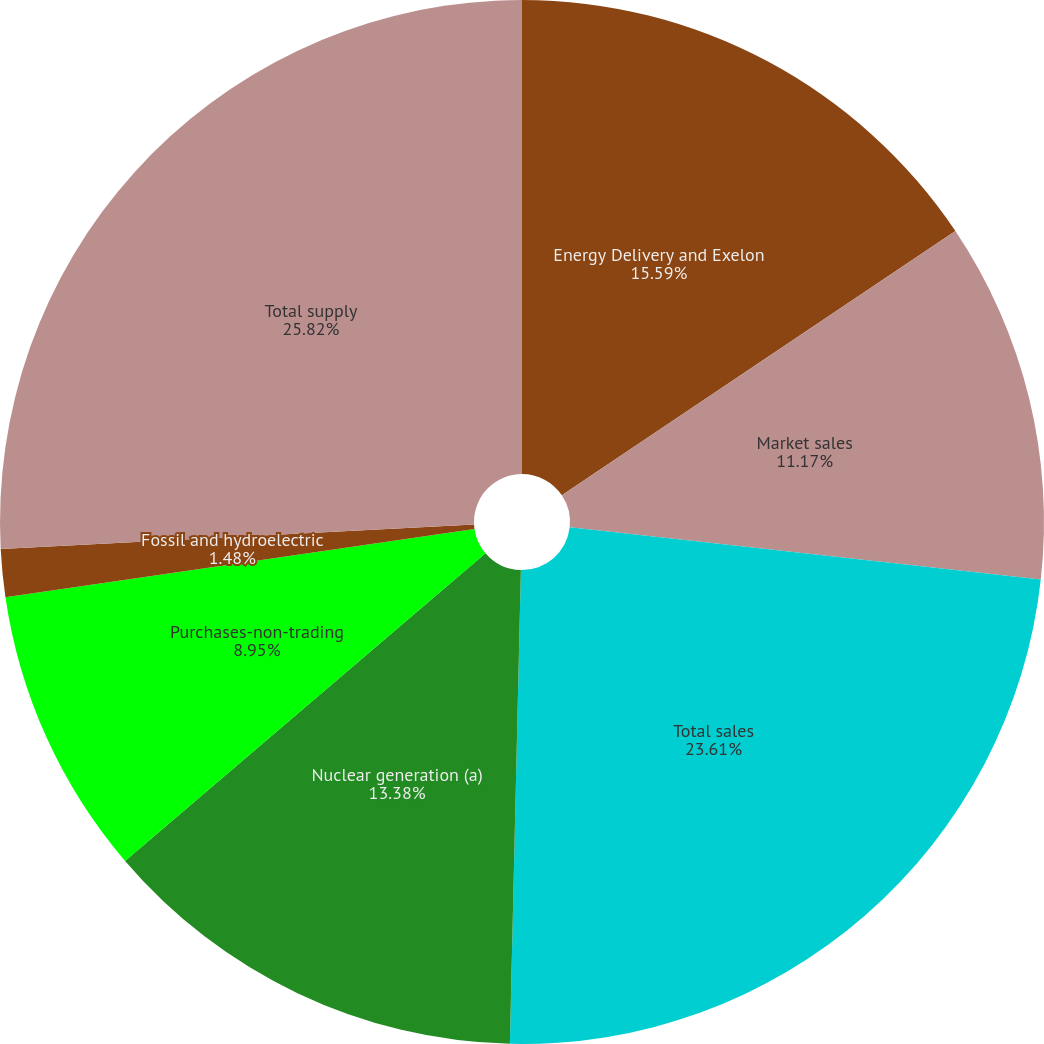<chart> <loc_0><loc_0><loc_500><loc_500><pie_chart><fcel>Energy Delivery and Exelon<fcel>Market sales<fcel>Total sales<fcel>Nuclear generation (a)<fcel>Purchases-non-trading<fcel>Fossil and hydroelectric<fcel>Total supply<nl><fcel>15.59%<fcel>11.17%<fcel>23.61%<fcel>13.38%<fcel>8.95%<fcel>1.48%<fcel>25.82%<nl></chart> 